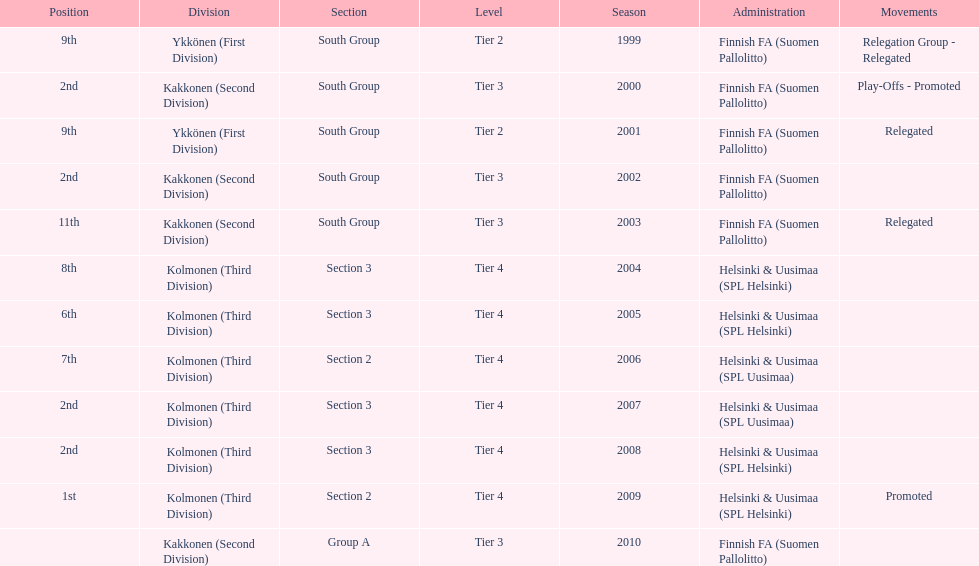Of the third division, how many were in section3? 4. 